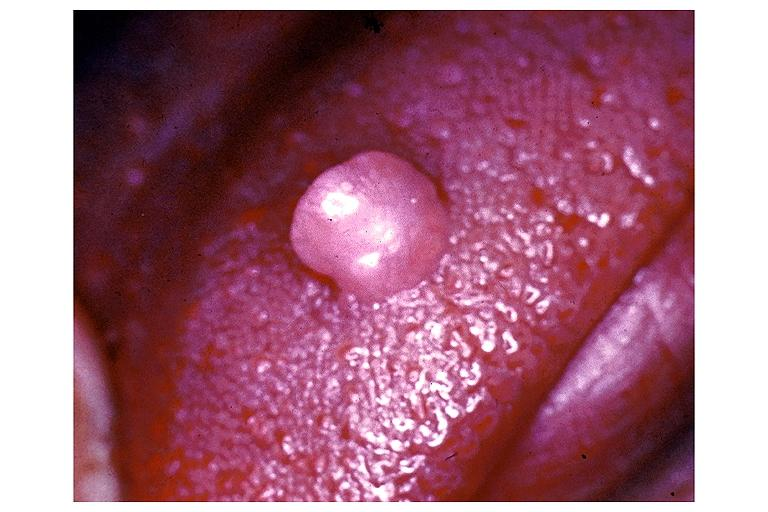does tetracycline show irritation fibroma?
Answer the question using a single word or phrase. No 